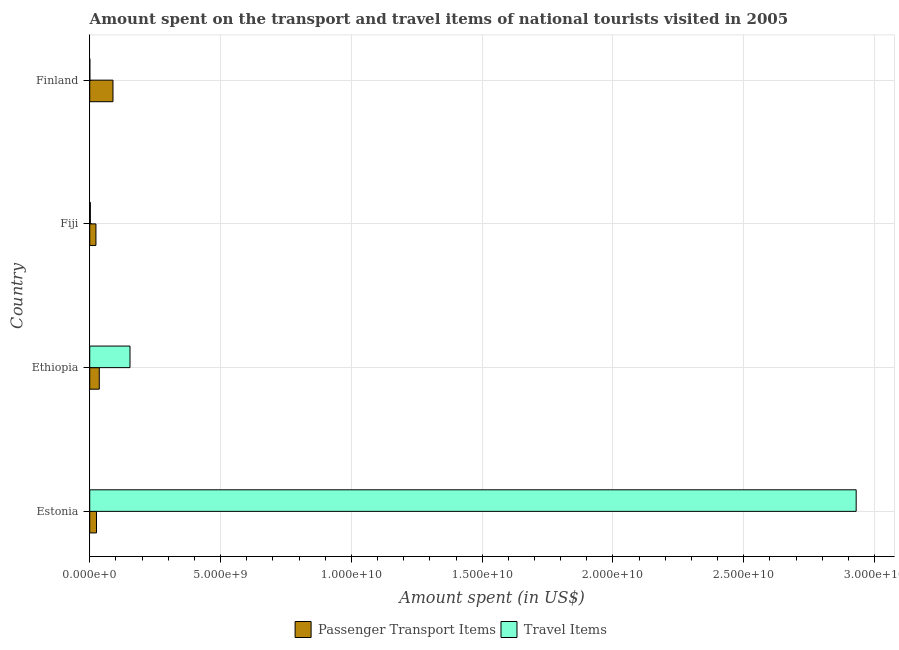How many groups of bars are there?
Give a very brief answer. 4. Are the number of bars on each tick of the Y-axis equal?
Your answer should be compact. Yes. What is the label of the 2nd group of bars from the top?
Your answer should be compact. Fiji. In how many cases, is the number of bars for a given country not equal to the number of legend labels?
Ensure brevity in your answer.  0. What is the amount spent in travel items in Finland?
Ensure brevity in your answer.  3.20e+06. Across all countries, what is the maximum amount spent in travel items?
Ensure brevity in your answer.  2.93e+1. Across all countries, what is the minimum amount spent on passenger transport items?
Your answer should be very brief. 2.37e+08. In which country was the amount spent in travel items maximum?
Offer a very short reply. Estonia. In which country was the amount spent on passenger transport items minimum?
Ensure brevity in your answer.  Fiji. What is the total amount spent in travel items in the graph?
Offer a very short reply. 3.09e+1. What is the difference between the amount spent on passenger transport items in Ethiopia and that in Finland?
Make the answer very short. -5.24e+08. What is the difference between the amount spent on passenger transport items in Ethiopia and the amount spent in travel items in Finland?
Provide a short and direct response. 3.62e+08. What is the average amount spent in travel items per country?
Your response must be concise. 7.72e+09. What is the difference between the amount spent in travel items and amount spent on passenger transport items in Fiji?
Provide a succinct answer. -2.13e+08. What is the ratio of the amount spent on passenger transport items in Fiji to that in Finland?
Your answer should be very brief. 0.27. Is the difference between the amount spent on passenger transport items in Estonia and Fiji greater than the difference between the amount spent in travel items in Estonia and Fiji?
Ensure brevity in your answer.  No. What is the difference between the highest and the second highest amount spent in travel items?
Your answer should be compact. 2.78e+1. What is the difference between the highest and the lowest amount spent on passenger transport items?
Make the answer very short. 6.52e+08. In how many countries, is the amount spent in travel items greater than the average amount spent in travel items taken over all countries?
Your answer should be compact. 1. What does the 2nd bar from the top in Ethiopia represents?
Your answer should be very brief. Passenger Transport Items. What does the 2nd bar from the bottom in Estonia represents?
Make the answer very short. Travel Items. How many bars are there?
Your response must be concise. 8. How many countries are there in the graph?
Your answer should be compact. 4. What is the difference between two consecutive major ticks on the X-axis?
Your answer should be very brief. 5.00e+09. Does the graph contain any zero values?
Offer a very short reply. No. Where does the legend appear in the graph?
Give a very brief answer. Bottom center. What is the title of the graph?
Provide a succinct answer. Amount spent on the transport and travel items of national tourists visited in 2005. Does "Travel Items" appear as one of the legend labels in the graph?
Offer a very short reply. Yes. What is the label or title of the X-axis?
Provide a short and direct response. Amount spent (in US$). What is the Amount spent (in US$) of Passenger Transport Items in Estonia?
Offer a very short reply. 2.58e+08. What is the Amount spent (in US$) in Travel Items in Estonia?
Provide a succinct answer. 2.93e+1. What is the Amount spent (in US$) in Passenger Transport Items in Ethiopia?
Provide a short and direct response. 3.65e+08. What is the Amount spent (in US$) in Travel Items in Ethiopia?
Provide a short and direct response. 1.54e+09. What is the Amount spent (in US$) of Passenger Transport Items in Fiji?
Provide a short and direct response. 2.37e+08. What is the Amount spent (in US$) of Travel Items in Fiji?
Give a very brief answer. 2.40e+07. What is the Amount spent (in US$) in Passenger Transport Items in Finland?
Offer a terse response. 8.89e+08. What is the Amount spent (in US$) in Travel Items in Finland?
Provide a short and direct response. 3.20e+06. Across all countries, what is the maximum Amount spent (in US$) of Passenger Transport Items?
Keep it short and to the point. 8.89e+08. Across all countries, what is the maximum Amount spent (in US$) of Travel Items?
Provide a short and direct response. 2.93e+1. Across all countries, what is the minimum Amount spent (in US$) of Passenger Transport Items?
Provide a succinct answer. 2.37e+08. Across all countries, what is the minimum Amount spent (in US$) in Travel Items?
Keep it short and to the point. 3.20e+06. What is the total Amount spent (in US$) of Passenger Transport Items in the graph?
Your answer should be very brief. 1.75e+09. What is the total Amount spent (in US$) in Travel Items in the graph?
Offer a terse response. 3.09e+1. What is the difference between the Amount spent (in US$) in Passenger Transport Items in Estonia and that in Ethiopia?
Your answer should be compact. -1.07e+08. What is the difference between the Amount spent (in US$) of Travel Items in Estonia and that in Ethiopia?
Keep it short and to the point. 2.78e+1. What is the difference between the Amount spent (in US$) of Passenger Transport Items in Estonia and that in Fiji?
Provide a short and direct response. 2.10e+07. What is the difference between the Amount spent (in US$) in Travel Items in Estonia and that in Fiji?
Provide a short and direct response. 2.93e+1. What is the difference between the Amount spent (in US$) in Passenger Transport Items in Estonia and that in Finland?
Your answer should be compact. -6.31e+08. What is the difference between the Amount spent (in US$) of Travel Items in Estonia and that in Finland?
Offer a terse response. 2.93e+1. What is the difference between the Amount spent (in US$) of Passenger Transport Items in Ethiopia and that in Fiji?
Make the answer very short. 1.28e+08. What is the difference between the Amount spent (in US$) in Travel Items in Ethiopia and that in Fiji?
Your answer should be very brief. 1.52e+09. What is the difference between the Amount spent (in US$) in Passenger Transport Items in Ethiopia and that in Finland?
Offer a very short reply. -5.24e+08. What is the difference between the Amount spent (in US$) of Travel Items in Ethiopia and that in Finland?
Provide a succinct answer. 1.54e+09. What is the difference between the Amount spent (in US$) of Passenger Transport Items in Fiji and that in Finland?
Your answer should be compact. -6.52e+08. What is the difference between the Amount spent (in US$) in Travel Items in Fiji and that in Finland?
Your answer should be very brief. 2.08e+07. What is the difference between the Amount spent (in US$) in Passenger Transport Items in Estonia and the Amount spent (in US$) in Travel Items in Ethiopia?
Your answer should be very brief. -1.28e+09. What is the difference between the Amount spent (in US$) of Passenger Transport Items in Estonia and the Amount spent (in US$) of Travel Items in Fiji?
Provide a short and direct response. 2.34e+08. What is the difference between the Amount spent (in US$) of Passenger Transport Items in Estonia and the Amount spent (in US$) of Travel Items in Finland?
Make the answer very short. 2.55e+08. What is the difference between the Amount spent (in US$) of Passenger Transport Items in Ethiopia and the Amount spent (in US$) of Travel Items in Fiji?
Give a very brief answer. 3.41e+08. What is the difference between the Amount spent (in US$) of Passenger Transport Items in Ethiopia and the Amount spent (in US$) of Travel Items in Finland?
Give a very brief answer. 3.62e+08. What is the difference between the Amount spent (in US$) of Passenger Transport Items in Fiji and the Amount spent (in US$) of Travel Items in Finland?
Provide a succinct answer. 2.34e+08. What is the average Amount spent (in US$) in Passenger Transport Items per country?
Your response must be concise. 4.37e+08. What is the average Amount spent (in US$) in Travel Items per country?
Your answer should be compact. 7.72e+09. What is the difference between the Amount spent (in US$) in Passenger Transport Items and Amount spent (in US$) in Travel Items in Estonia?
Give a very brief answer. -2.90e+1. What is the difference between the Amount spent (in US$) of Passenger Transport Items and Amount spent (in US$) of Travel Items in Ethiopia?
Offer a very short reply. -1.17e+09. What is the difference between the Amount spent (in US$) in Passenger Transport Items and Amount spent (in US$) in Travel Items in Fiji?
Offer a very short reply. 2.13e+08. What is the difference between the Amount spent (in US$) in Passenger Transport Items and Amount spent (in US$) in Travel Items in Finland?
Offer a terse response. 8.86e+08. What is the ratio of the Amount spent (in US$) of Passenger Transport Items in Estonia to that in Ethiopia?
Your response must be concise. 0.71. What is the ratio of the Amount spent (in US$) in Travel Items in Estonia to that in Ethiopia?
Offer a very short reply. 19.04. What is the ratio of the Amount spent (in US$) of Passenger Transport Items in Estonia to that in Fiji?
Your answer should be very brief. 1.09. What is the ratio of the Amount spent (in US$) of Travel Items in Estonia to that in Fiji?
Your answer should be very brief. 1220.67. What is the ratio of the Amount spent (in US$) of Passenger Transport Items in Estonia to that in Finland?
Make the answer very short. 0.29. What is the ratio of the Amount spent (in US$) in Travel Items in Estonia to that in Finland?
Offer a terse response. 9155. What is the ratio of the Amount spent (in US$) in Passenger Transport Items in Ethiopia to that in Fiji?
Give a very brief answer. 1.54. What is the ratio of the Amount spent (in US$) of Travel Items in Ethiopia to that in Fiji?
Provide a short and direct response. 64.12. What is the ratio of the Amount spent (in US$) of Passenger Transport Items in Ethiopia to that in Finland?
Your answer should be very brief. 0.41. What is the ratio of the Amount spent (in US$) in Travel Items in Ethiopia to that in Finland?
Your answer should be compact. 480.94. What is the ratio of the Amount spent (in US$) in Passenger Transport Items in Fiji to that in Finland?
Offer a terse response. 0.27. What is the difference between the highest and the second highest Amount spent (in US$) in Passenger Transport Items?
Keep it short and to the point. 5.24e+08. What is the difference between the highest and the second highest Amount spent (in US$) in Travel Items?
Provide a short and direct response. 2.78e+1. What is the difference between the highest and the lowest Amount spent (in US$) of Passenger Transport Items?
Make the answer very short. 6.52e+08. What is the difference between the highest and the lowest Amount spent (in US$) in Travel Items?
Your answer should be compact. 2.93e+1. 